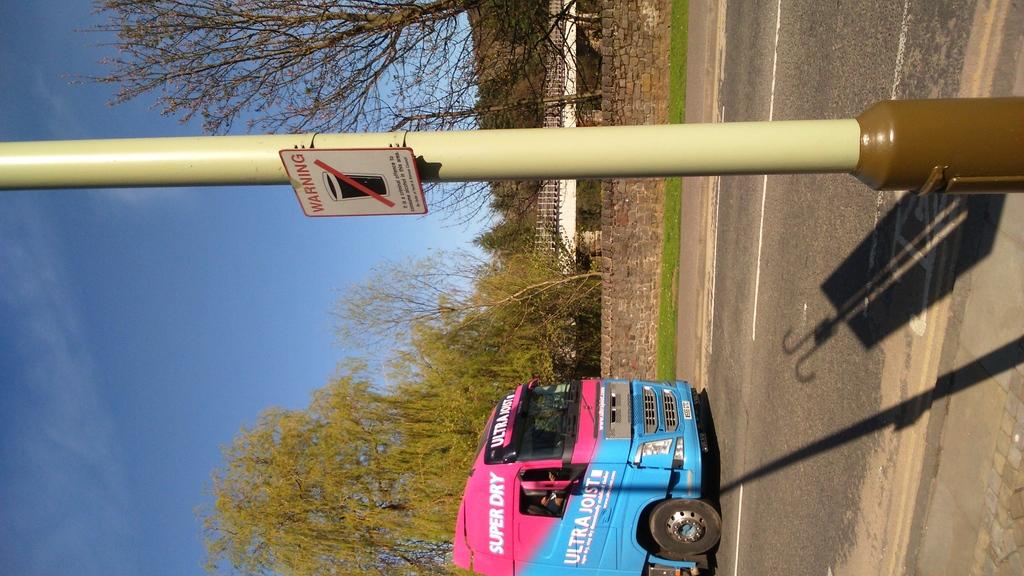Is that a warning sign?
Provide a short and direct response. Yes. What is the bus name?
Keep it short and to the point. Ultra joist. 